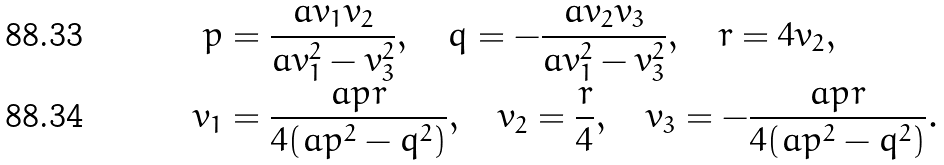<formula> <loc_0><loc_0><loc_500><loc_500>p & = \frac { a v _ { 1 } v _ { 2 } } { a v _ { 1 } ^ { 2 } - v _ { 3 } ^ { 2 } } , \quad q = - \frac { a v _ { 2 } v _ { 3 } } { a v _ { 1 } ^ { 2 } - v _ { 3 } ^ { 2 } } , \quad r = 4 v _ { 2 } , \\ v _ { 1 } & = \frac { a p r } { 4 ( a p ^ { 2 } - q ^ { 2 } ) } , \quad v _ { 2 } = \frac { r } { 4 } , \quad v _ { 3 } = - \frac { a p r } { 4 ( a p ^ { 2 } - q ^ { 2 } ) } .</formula> 